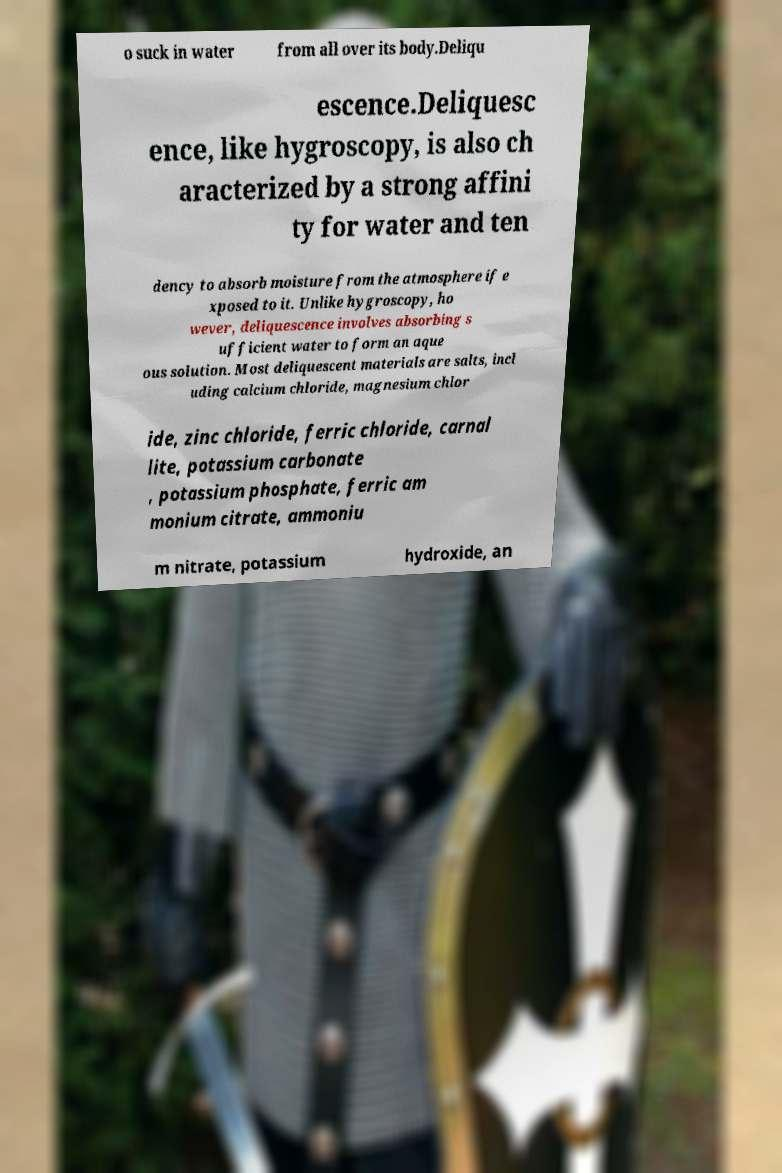Please identify and transcribe the text found in this image. o suck in water from all over its body.Deliqu escence.Deliquesc ence, like hygroscopy, is also ch aracterized by a strong affini ty for water and ten dency to absorb moisture from the atmosphere if e xposed to it. Unlike hygroscopy, ho wever, deliquescence involves absorbing s ufficient water to form an aque ous solution. Most deliquescent materials are salts, incl uding calcium chloride, magnesium chlor ide, zinc chloride, ferric chloride, carnal lite, potassium carbonate , potassium phosphate, ferric am monium citrate, ammoniu m nitrate, potassium hydroxide, an 